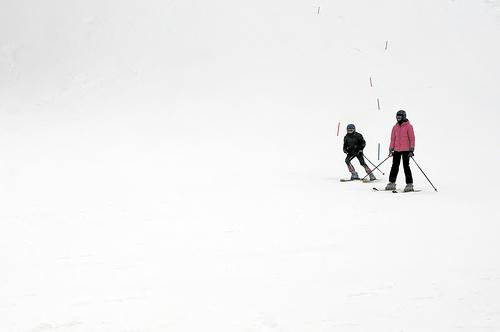Describe the skiing-related accessories in the image. There are skis, ski poles, black and white skully on heads, skiing jackets, gloves, helmets, and an orange pole in snow. What task involves finding and pointing out a specific item in the image based on its description? Referential expression grounding task What item in the image is orange and located in the snow? An orange pole Based on details provided about this image, can we use this for a product advertisement task? Why or why not?  Yes, because the image contains skiing gear and outfits which can be used to advertise ski-related products. Identify the colors of the jackets worn by two kids in the image. One kid is wearing a pink jacket and the other kid is wearing a black jacket. Select the relevant task: Choose the best caption for the image from a list of given captions. Multi-choice VQA task What color is the helmet on the skier's head? Black and white What is the primary activity taking place in this picture? Skiing in the snow Choose the correct alternative: Who is wearing a pink jacket: a person, a kid or both? Both Which task would involve analyzing and extracting information from the image descriptions? Visual entailment task 